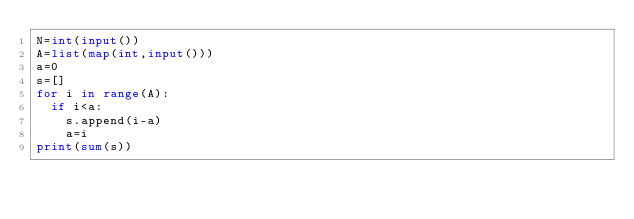<code> <loc_0><loc_0><loc_500><loc_500><_Python_>N=int(input())
A=list(map(int,input()))
a=0
s=[]
for i in range(A):
  if i<a:
    s.append(i-a)
    a=i
print(sum(s))
      
  
    </code> 